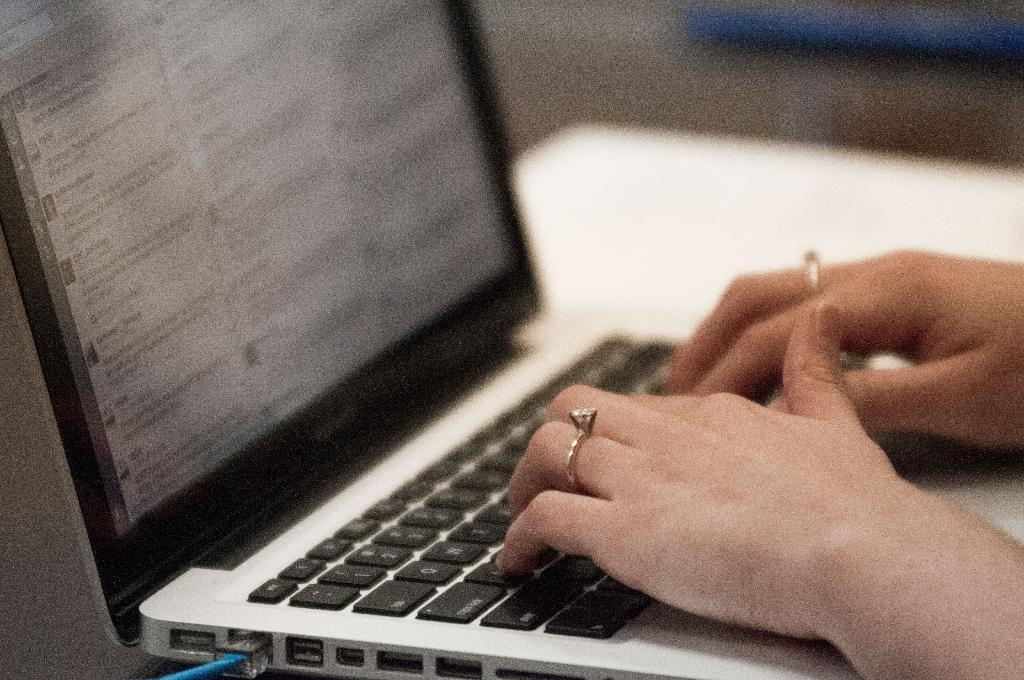<image>
Offer a succinct explanation of the picture presented. a woman typing on a keyboard with keys like CAPS Lock 